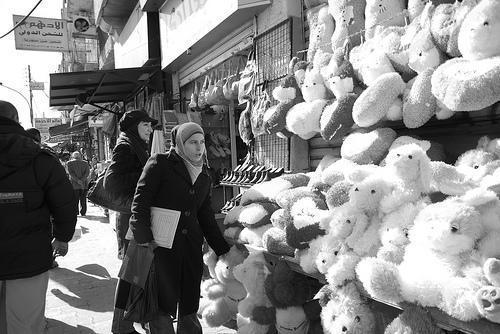How many dark colored stuffed animals are there?
Give a very brief answer. 4. 